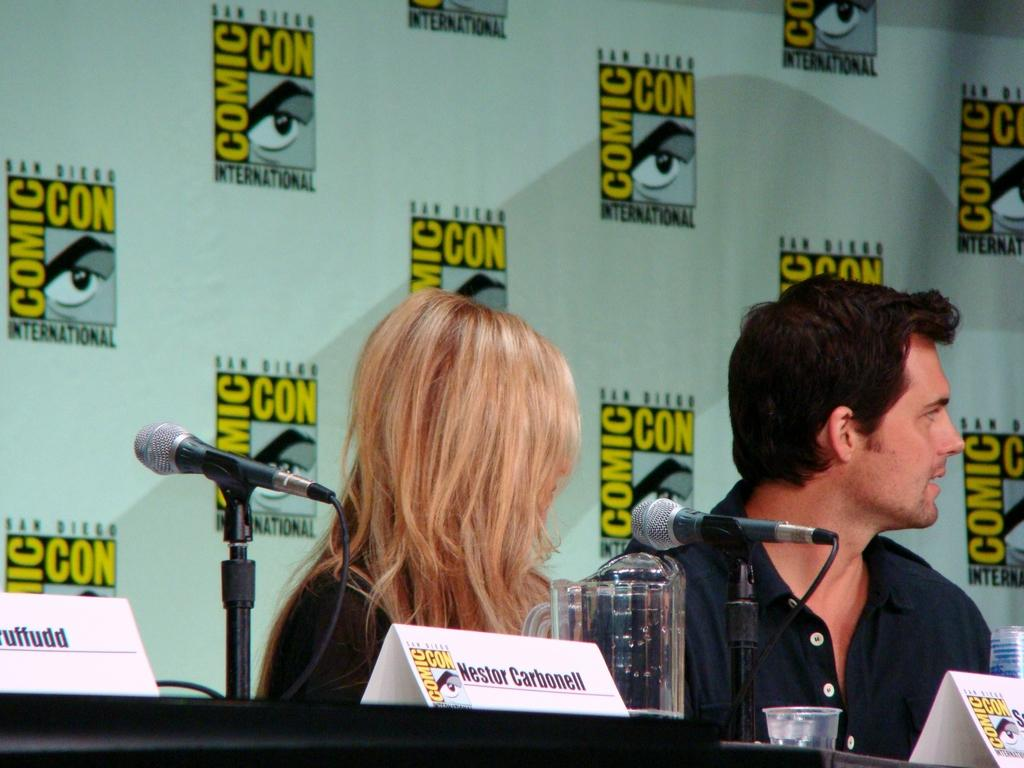How many people are in the image? There are people in the image, but the exact number cannot be determined from the provided facts. What is in front of the people? There is a table in front of the people. What items can be seen on the table? There are microphones and name boards on the table. What type of containers are visible in the image? There is a jar and a glass in the image. What is behind the people? There is a banner behind the people. What type of pies are being served on the table in the image? There is no mention of pies in the provided facts, so it cannot be determined if any are present in the image. 